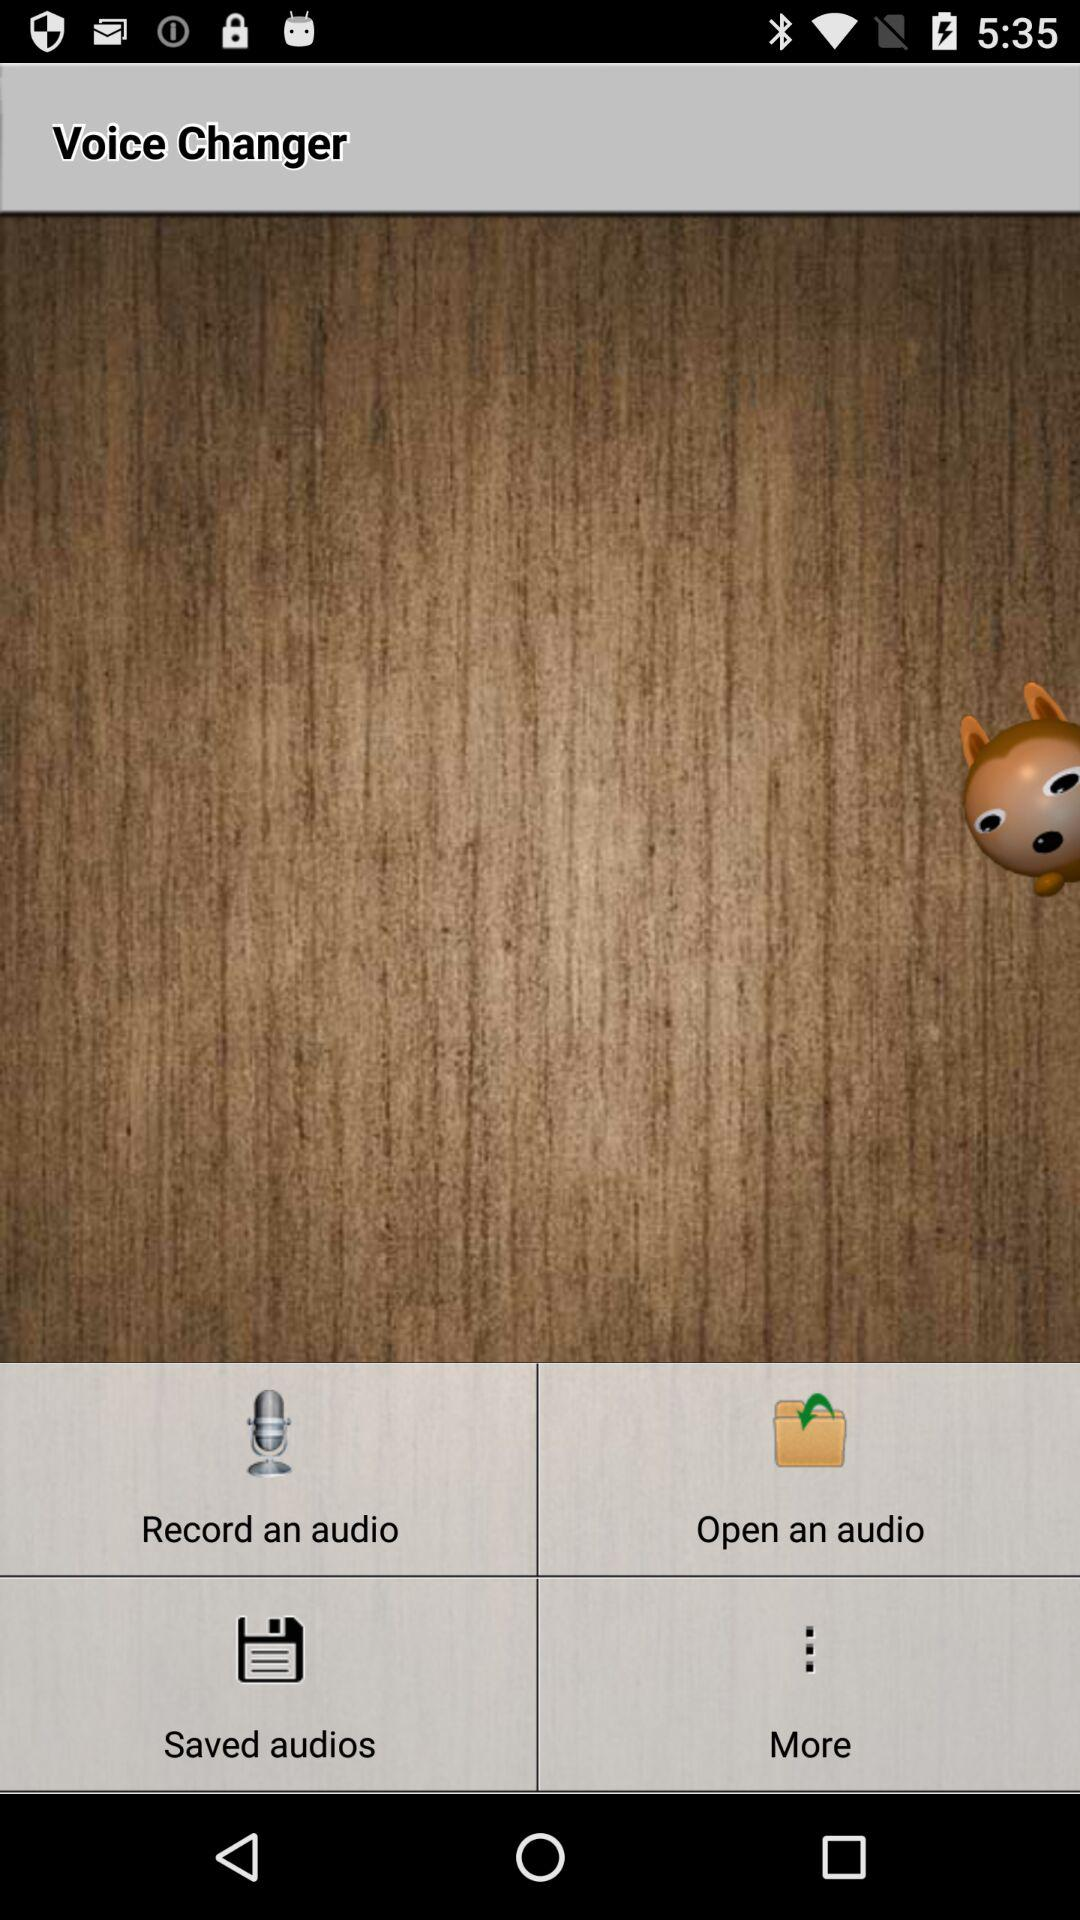Which audio files are saved?
When the provided information is insufficient, respond with <no answer>. <no answer> 